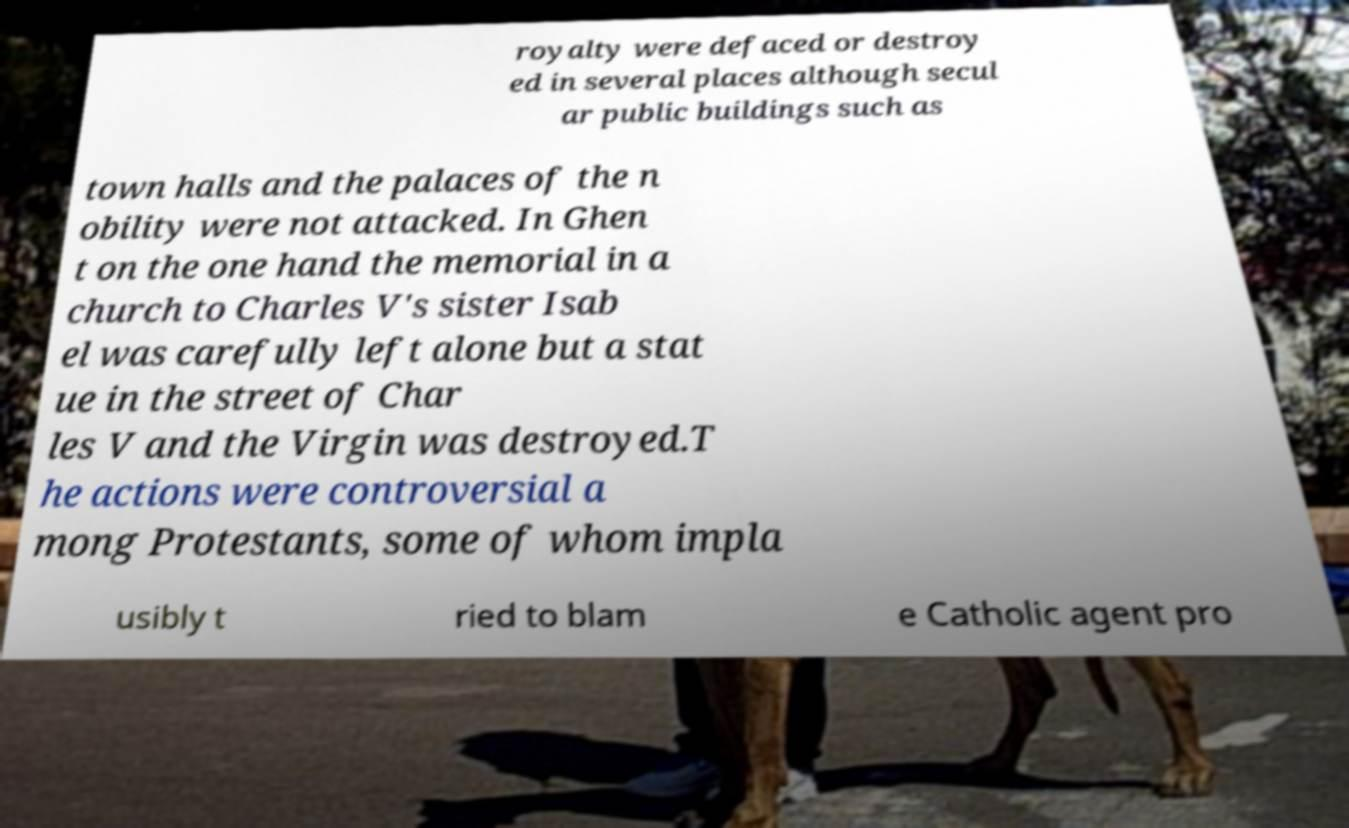Can you read and provide the text displayed in the image?This photo seems to have some interesting text. Can you extract and type it out for me? royalty were defaced or destroy ed in several places although secul ar public buildings such as town halls and the palaces of the n obility were not attacked. In Ghen t on the one hand the memorial in a church to Charles V's sister Isab el was carefully left alone but a stat ue in the street of Char les V and the Virgin was destroyed.T he actions were controversial a mong Protestants, some of whom impla usibly t ried to blam e Catholic agent pro 